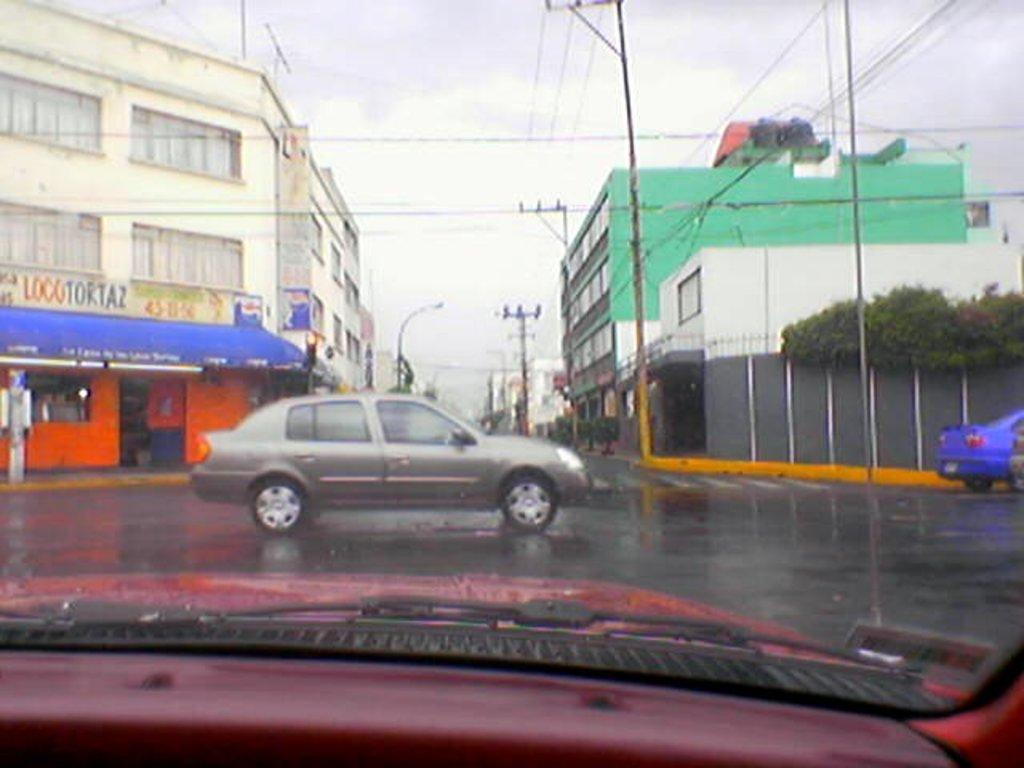What is happening on the road in the image? Vehicles are moving on the road. What can be seen on both sides of the road? There are buildings on either side of the road. Can you identify any other objects in the image? Yes, there is a pole in the image. What type of hair can be seen on the bed in the image? There is no bed or hair present in the image; it features vehicles moving on a road with buildings and a pole. 